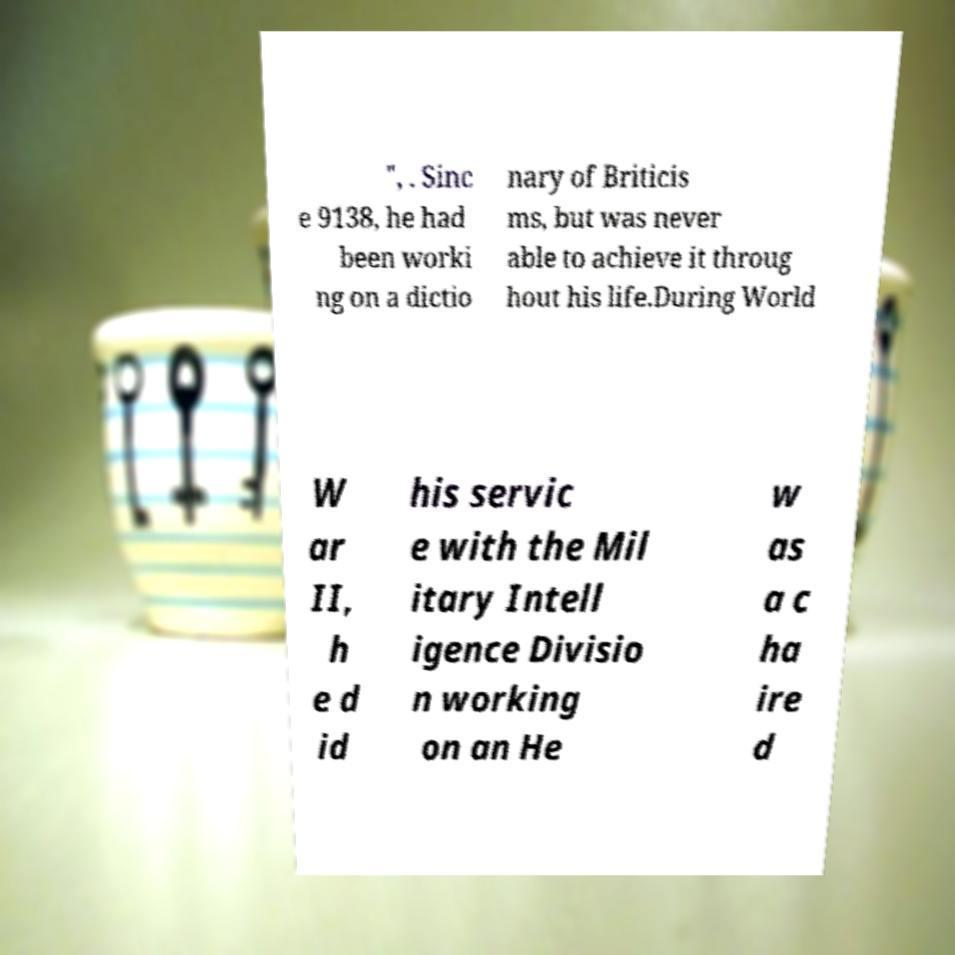Can you read and provide the text displayed in the image?This photo seems to have some interesting text. Can you extract and type it out for me? ", . Sinc e 9138, he had been worki ng on a dictio nary of Briticis ms, but was never able to achieve it throug hout his life.During World W ar II, h e d id his servic e with the Mil itary Intell igence Divisio n working on an He w as a c ha ire d 